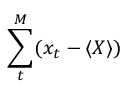Convert formula to latex. <formula><loc_0><loc_0><loc_500><loc_500>\sum _ { t } ^ { M } ( x _ { t } - \langle X \rangle )</formula> 